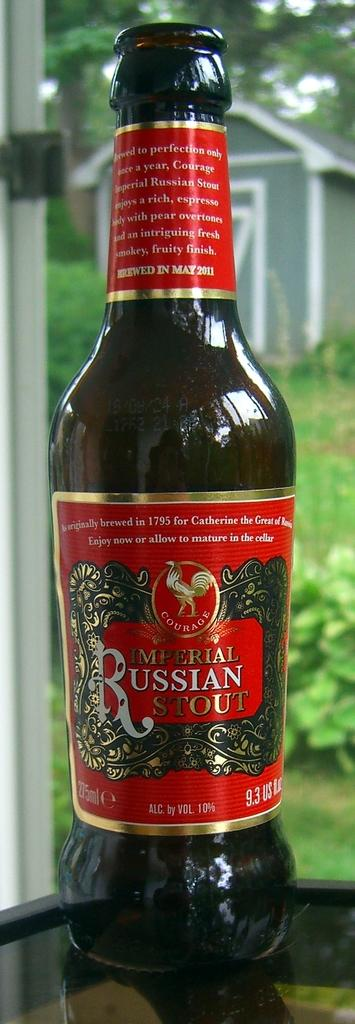<image>
Describe the image concisely. a close up of Imperial Russian Stout by a window 